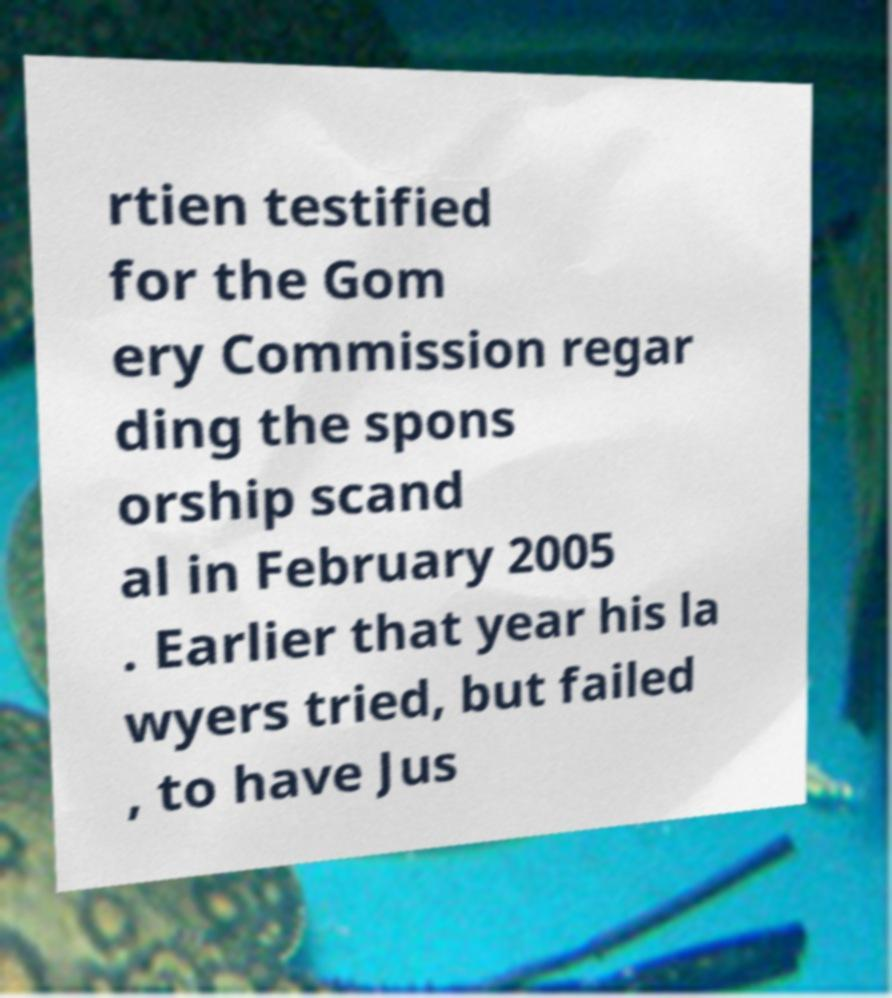Please read and relay the text visible in this image. What does it say? rtien testified for the Gom ery Commission regar ding the spons orship scand al in February 2005 . Earlier that year his la wyers tried, but failed , to have Jus 